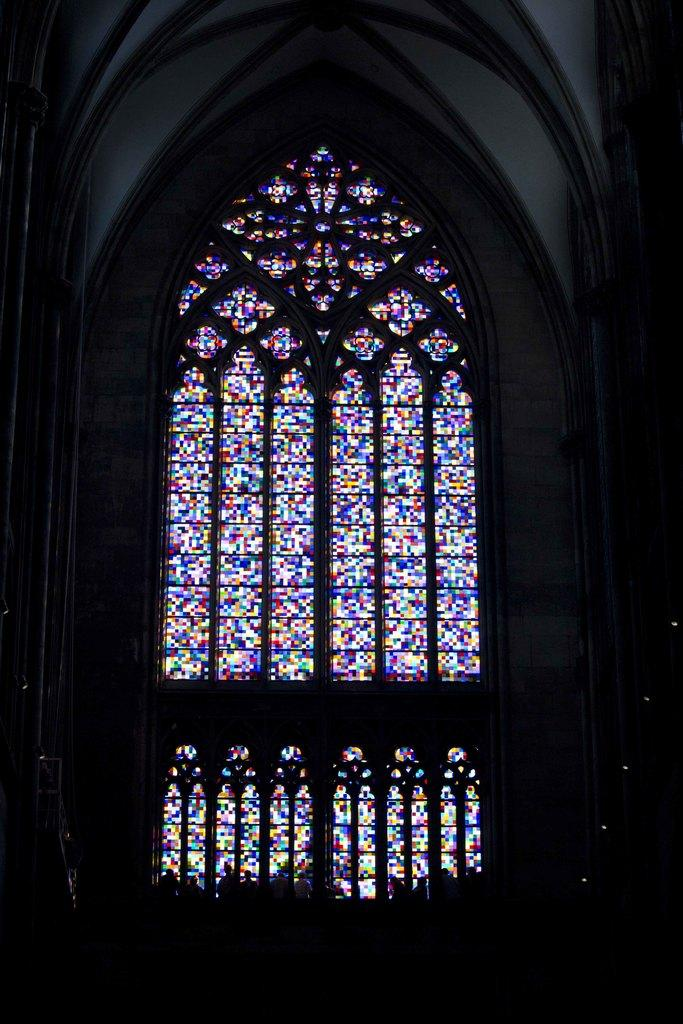What is the main structure visible in the image? There is a building wall in the image. Are there any openings in the building wall? Yes, there is a window in the image. Can you describe the setting of the image? The image may have been taken in a church, but this cannot be confirmed without additional context or information. What type of leather is being used to make the war drums in the image? There is no mention of war drums or leather in the image, so this question cannot be answered definitively. 